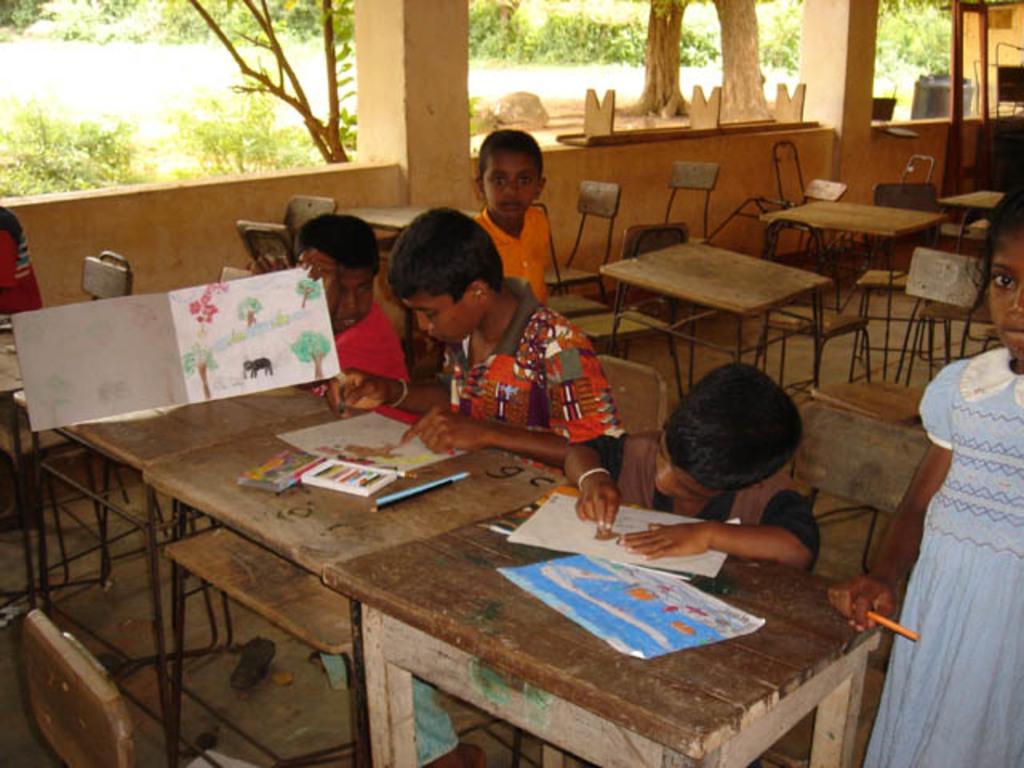How would you summarize this image in a sentence or two? Here we can see children sitting on chairs with benches in front of them, they are drawing on a paper and behind them we can see greenery 